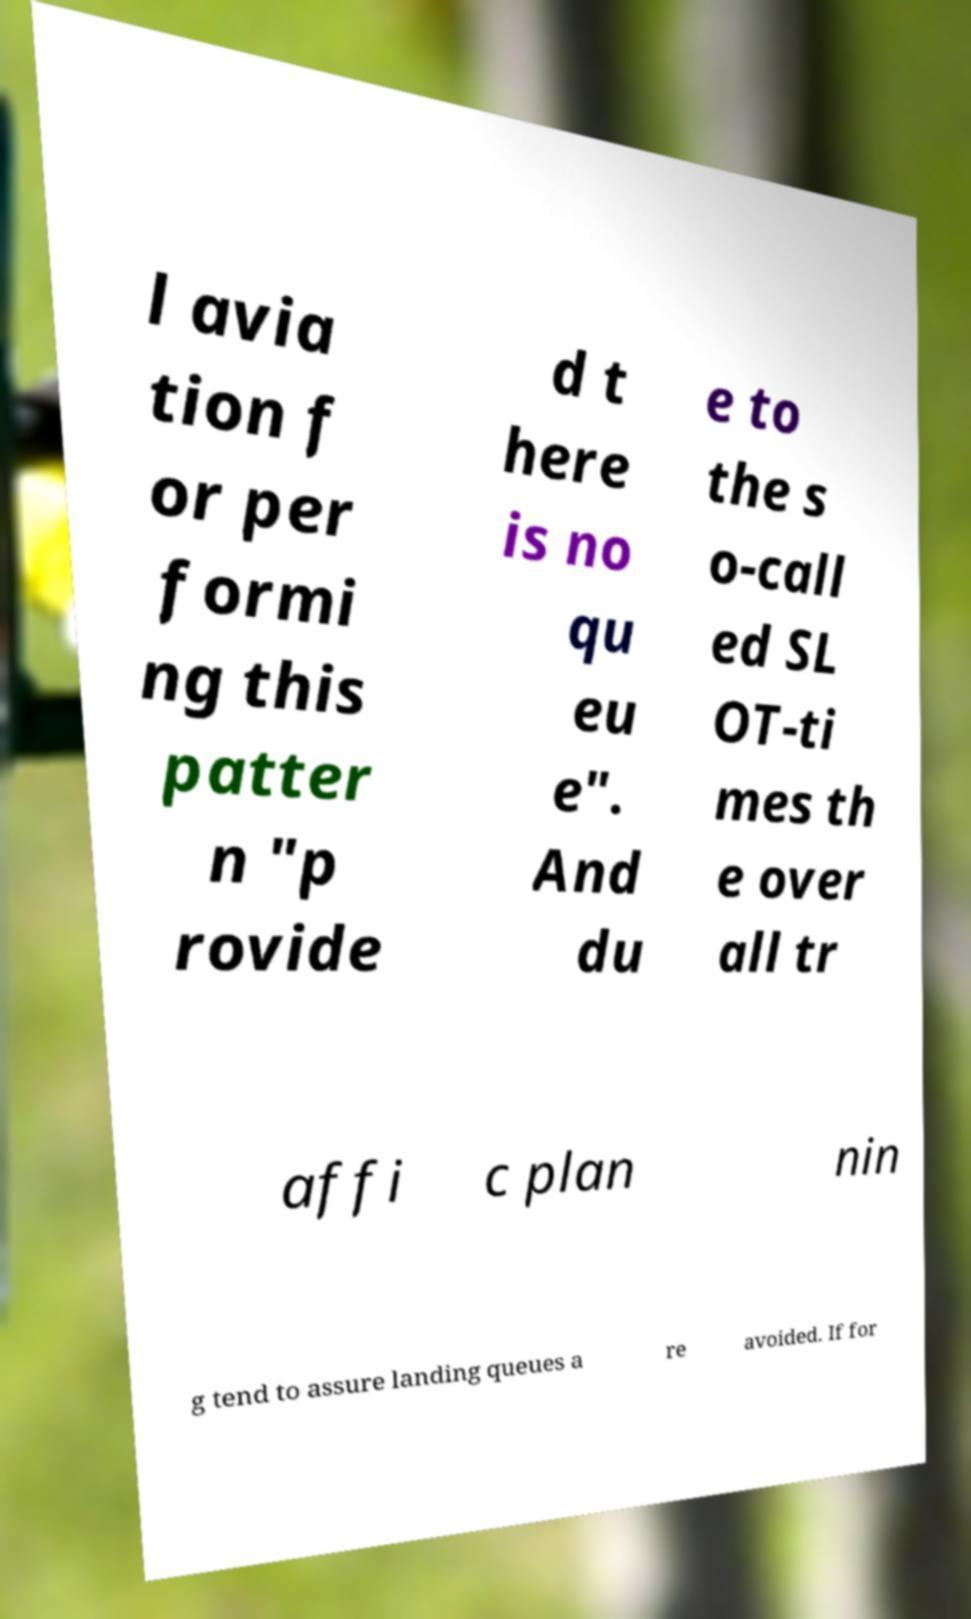What messages or text are displayed in this image? I need them in a readable, typed format. l avia tion f or per formi ng this patter n "p rovide d t here is no qu eu e". And du e to the s o-call ed SL OT-ti mes th e over all tr affi c plan nin g tend to assure landing queues a re avoided. If for 